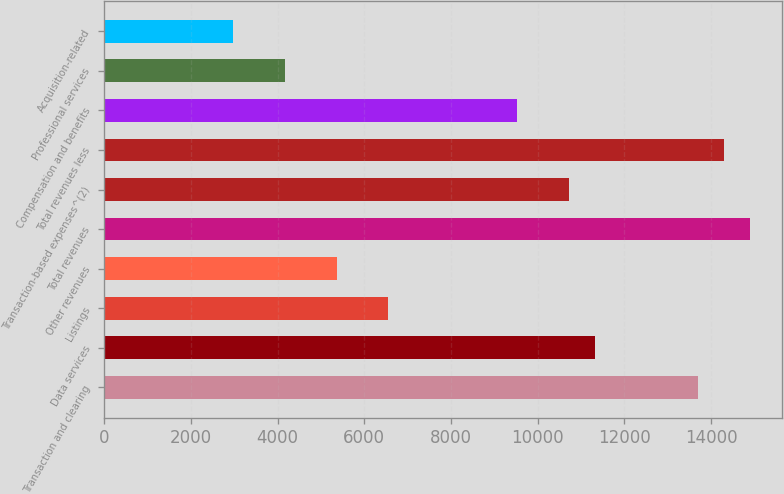<chart> <loc_0><loc_0><loc_500><loc_500><bar_chart><fcel>Transaction and clearing<fcel>Data services<fcel>Listings<fcel>Other revenues<fcel>Total revenues<fcel>Transaction-based expenses^(2)<fcel>Total revenues less<fcel>Compensation and benefits<fcel>Professional services<fcel>Acquisition-related<nl><fcel>13702.5<fcel>11319.5<fcel>6553.71<fcel>5362.25<fcel>14893.9<fcel>10723.8<fcel>14298.2<fcel>9532.36<fcel>4170.79<fcel>2979.33<nl></chart> 